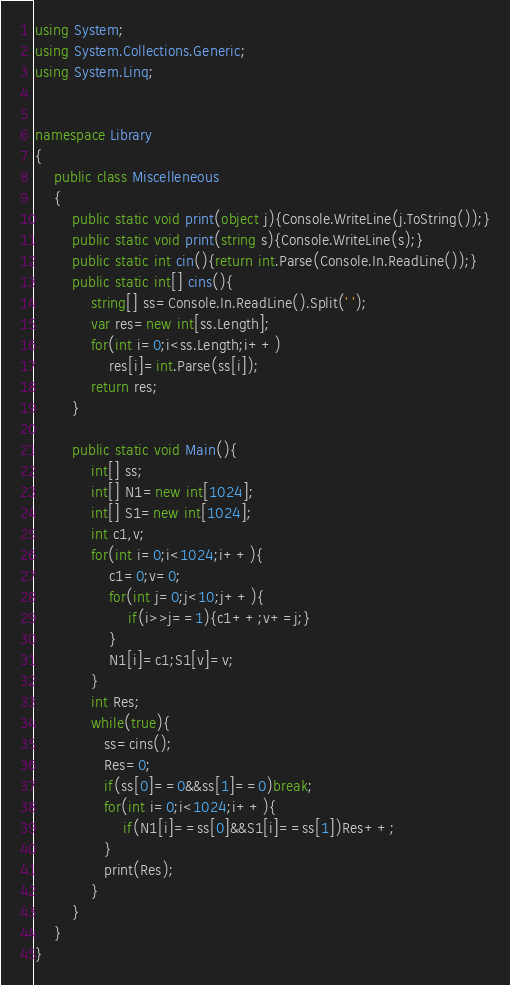Convert code to text. <code><loc_0><loc_0><loc_500><loc_500><_C#_>using System;
using System.Collections.Generic;
using System.Linq;


namespace Library
{
    public class Miscelleneous
    {
        public static void print(object j){Console.WriteLine(j.ToString());}
        public static void print(string s){Console.WriteLine(s);}
        public static int cin(){return int.Parse(Console.In.ReadLine());}
        public static int[] cins(){
            string[] ss=Console.In.ReadLine().Split(' ');
            var res=new int[ss.Length];
            for(int i=0;i<ss.Length;i++)
                res[i]=int.Parse(ss[i]);                
            return res;            
        }
        
        public static void Main(){
            int[] ss;
            int[] N1=new int[1024];
            int[] S1=new int[1024];
            int c1,v;
            for(int i=0;i<1024;i++){
                c1=0;v=0;
                for(int j=0;j<10;j++){
                    if(i>>j==1){c1++;v+=j;}
                }
                N1[i]=c1;S1[v]=v;
            }
            int Res;
            while(true){
               ss=cins();
               Res=0;
               if(ss[0]==0&&ss[1]==0)break;
               for(int i=0;i<1024;i++){
                   if(N1[i]==ss[0]&&S1[i]==ss[1])Res++;
               }
               print(Res); 
            }
        }
    }
}</code> 